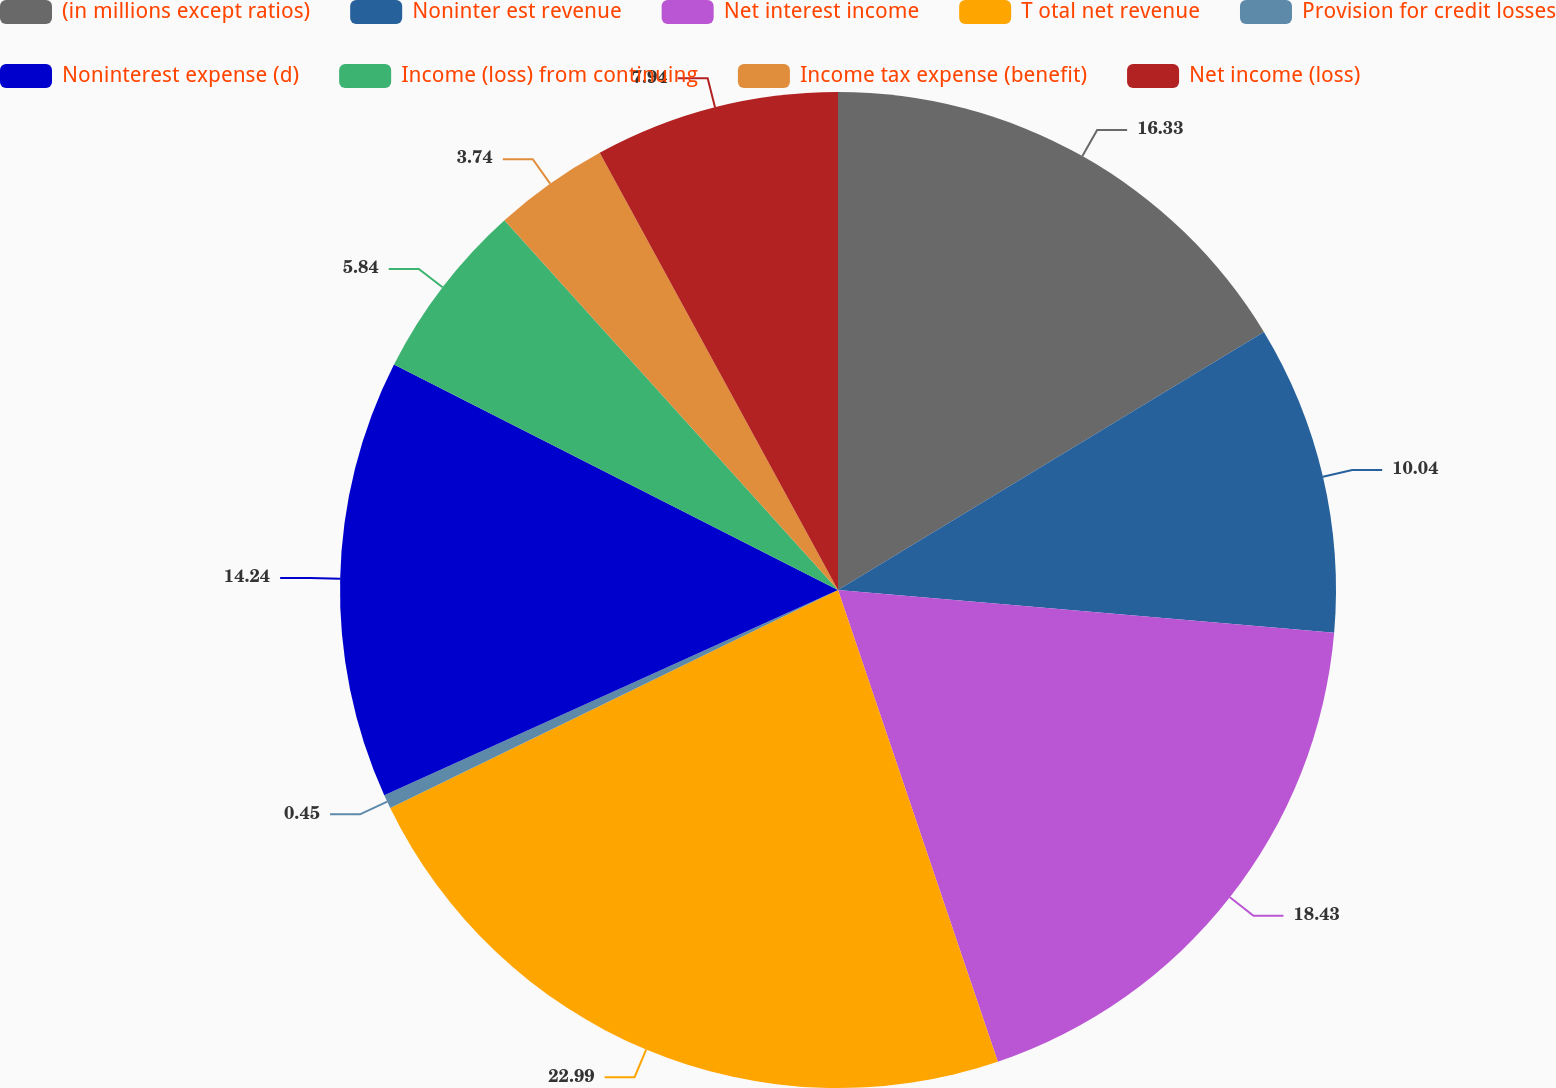<chart> <loc_0><loc_0><loc_500><loc_500><pie_chart><fcel>(in millions except ratios)<fcel>Noninter est revenue<fcel>Net interest income<fcel>T otal net revenue<fcel>Provision for credit losses<fcel>Noninterest expense (d)<fcel>Income (loss) from continuing<fcel>Income tax expense (benefit)<fcel>Net income (loss)<nl><fcel>16.33%<fcel>10.04%<fcel>18.43%<fcel>22.99%<fcel>0.45%<fcel>14.24%<fcel>5.84%<fcel>3.74%<fcel>7.94%<nl></chart> 